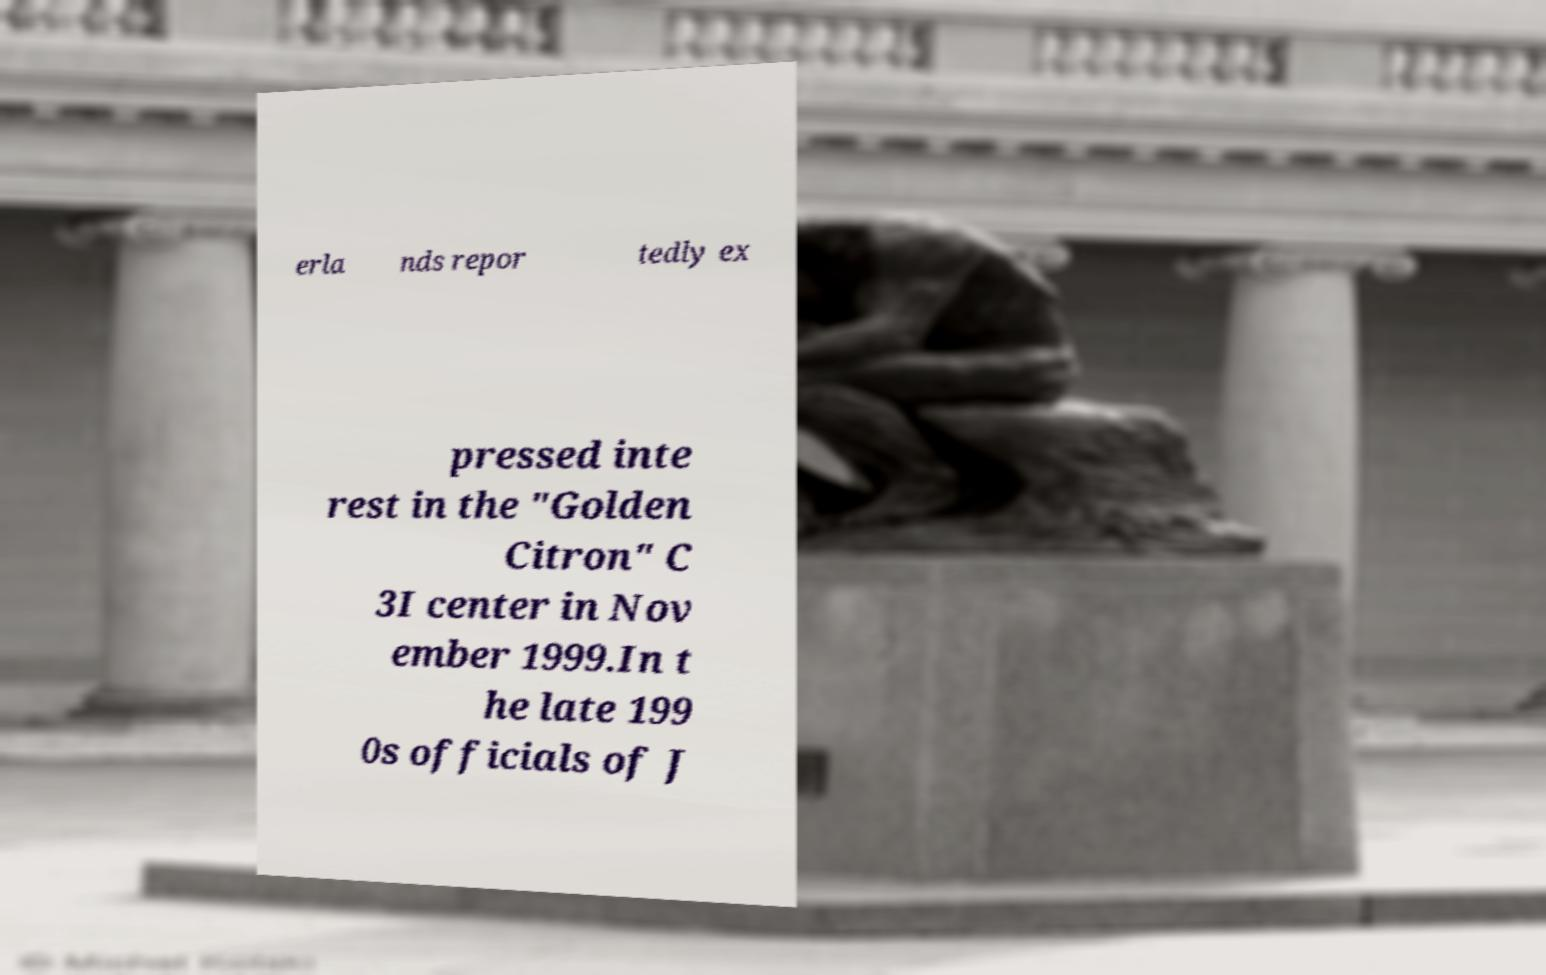Could you extract and type out the text from this image? erla nds repor tedly ex pressed inte rest in the "Golden Citron" C 3I center in Nov ember 1999.In t he late 199 0s officials of J 